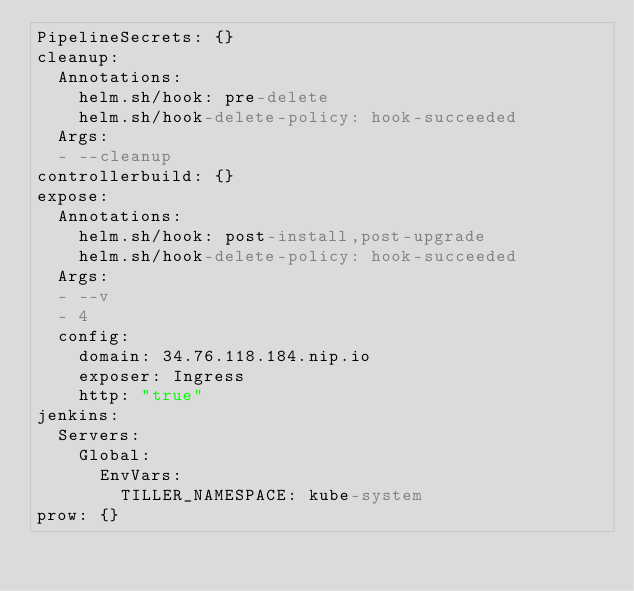Convert code to text. <code><loc_0><loc_0><loc_500><loc_500><_YAML_>PipelineSecrets: {}
cleanup:
  Annotations:
    helm.sh/hook: pre-delete
    helm.sh/hook-delete-policy: hook-succeeded
  Args:
  - --cleanup
controllerbuild: {}
expose:
  Annotations:
    helm.sh/hook: post-install,post-upgrade
    helm.sh/hook-delete-policy: hook-succeeded
  Args:
  - --v
  - 4
  config:
    domain: 34.76.118.184.nip.io
    exposer: Ingress
    http: "true"
jenkins:
  Servers:
    Global:
      EnvVars:
        TILLER_NAMESPACE: kube-system
prow: {}
</code> 